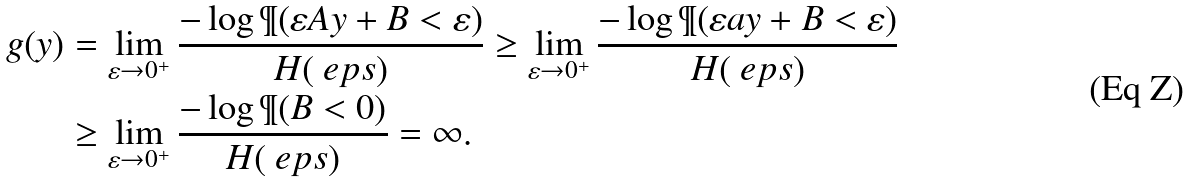<formula> <loc_0><loc_0><loc_500><loc_500>g ( y ) & = \lim _ { \varepsilon \to 0 ^ { + } } \frac { - \log \P ( \varepsilon A y + B < \varepsilon ) } { H ( \ e p s ) } \geq \lim _ { \varepsilon \to 0 ^ { + } } \frac { - \log \P ( \varepsilon a y + B < \varepsilon ) } { H ( \ e p s ) } \\ & \geq \lim _ { \varepsilon \to 0 ^ { + } } \frac { - \log \P ( B < 0 ) } { H ( \ e p s ) } = \infty .</formula> 